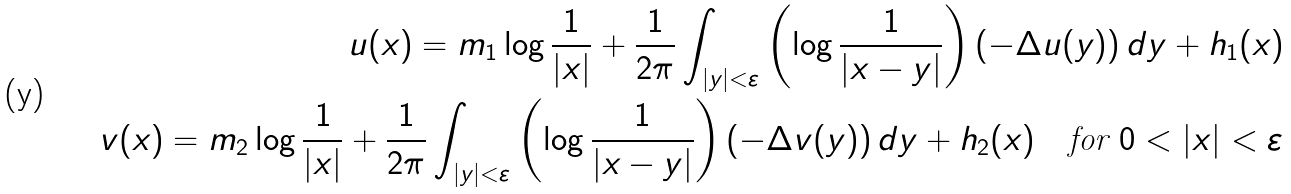<formula> <loc_0><loc_0><loc_500><loc_500>u ( x ) = m _ { 1 } \log \frac { 1 } { | x | } + \frac { 1 } { 2 \pi } \int _ { | y | < \varepsilon } \left ( \log \frac { 1 } { | x - y | } \right ) ( - \Delta u ( y ) ) \, d y + h _ { 1 } ( x ) \\ v ( x ) = m _ { 2 } \log \frac { 1 } { | x | } + \frac { 1 } { 2 \pi } \int _ { | y | < \varepsilon } \left ( \log \frac { 1 } { | x - y | } \right ) ( - \Delta v ( y ) ) \, d y + h _ { 2 } ( x ) \quad \text {for } 0 < | x | < \varepsilon</formula> 